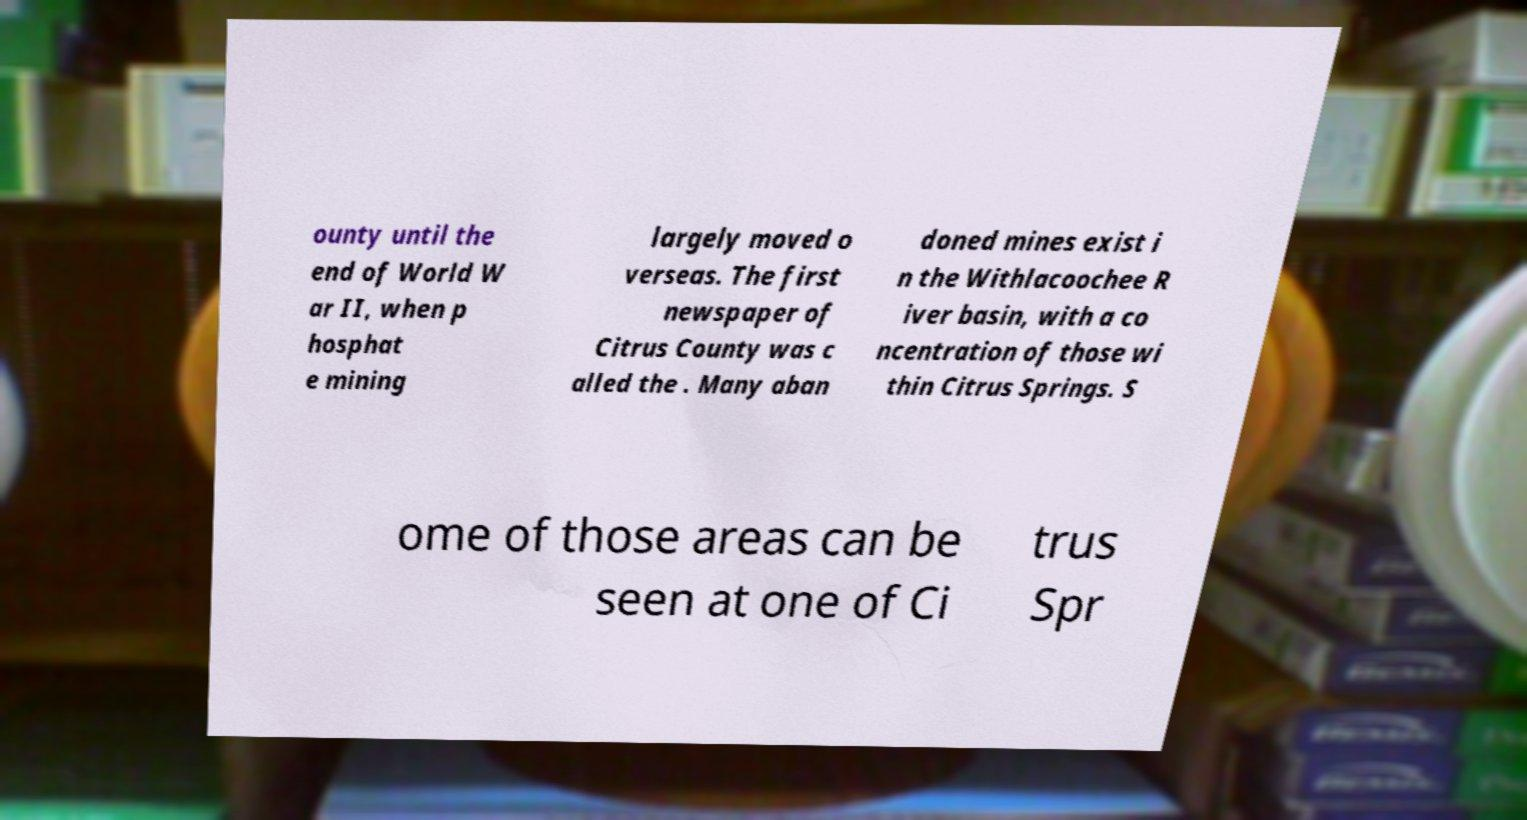For documentation purposes, I need the text within this image transcribed. Could you provide that? ounty until the end of World W ar II, when p hosphat e mining largely moved o verseas. The first newspaper of Citrus County was c alled the . Many aban doned mines exist i n the Withlacoochee R iver basin, with a co ncentration of those wi thin Citrus Springs. S ome of those areas can be seen at one of Ci trus Spr 